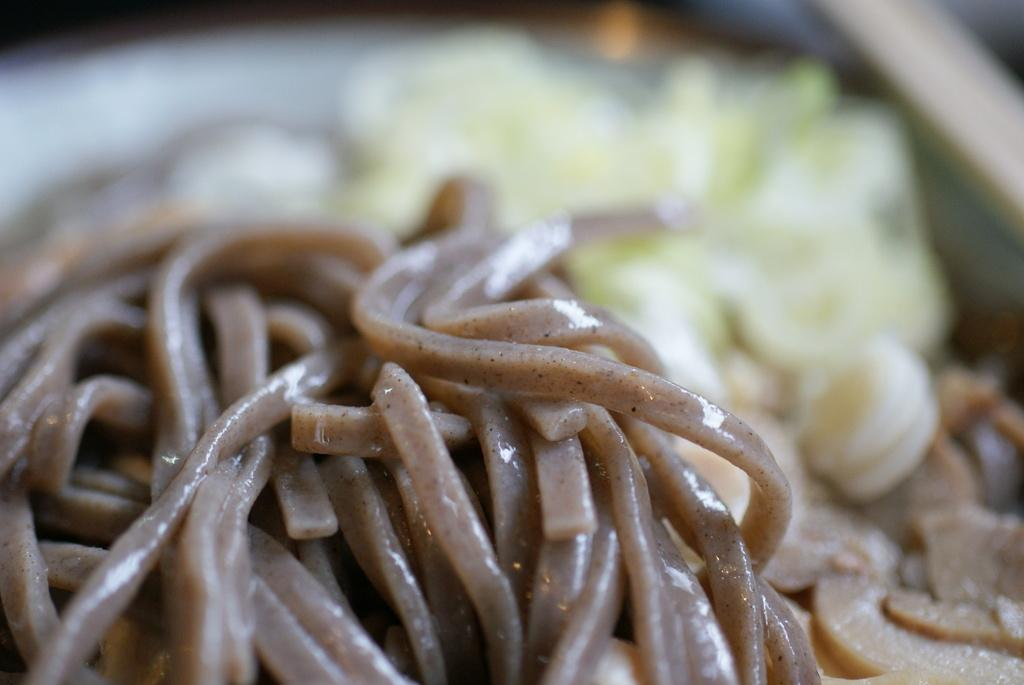What type of food is the main subject of the image? There are noodles in the image. Are there any other types of food visible in the image? Yes, there is other food visible in the image. What type of brush is used to cook the noodles in the image? There is no brush present in the image, and the noodles are not being cooked; they are already prepared and visible in the image. 